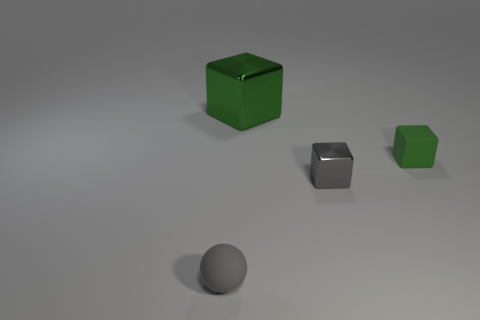Add 1 tiny blue matte objects. How many objects exist? 5 Subtract all balls. How many objects are left? 3 Subtract all brown metallic spheres. Subtract all gray matte balls. How many objects are left? 3 Add 1 small green things. How many small green things are left? 2 Add 4 gray rubber spheres. How many gray rubber spheres exist? 5 Subtract 0 blue cylinders. How many objects are left? 4 